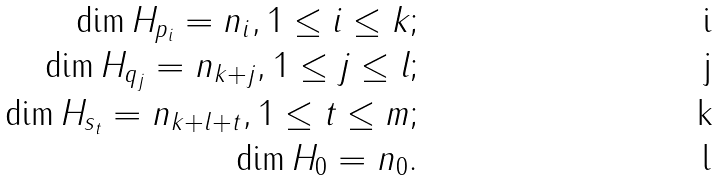<formula> <loc_0><loc_0><loc_500><loc_500>\dim H _ { p _ { i } } = n _ { i } , 1 \leq i \leq k ; \\ \dim H _ { q _ { j } } = n _ { k + j } , 1 \leq j \leq l ; \\ \dim H _ { s _ { t } } = n _ { k + l + t } , 1 \leq t \leq m ; \\ \dim H _ { 0 } = n _ { 0 } .</formula> 